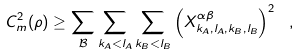Convert formula to latex. <formula><loc_0><loc_0><loc_500><loc_500>C ^ { 2 } _ { m } ( \rho ) \geq \sum _ { \mathcal { B } } \sum _ { k _ { A } < l _ { A } } \sum _ { k _ { B } < l _ { B } } \left ( X _ { k _ { A } , l _ { A } , k _ { B } , l _ { B } } ^ { \alpha \beta } \right ) ^ { 2 } \ ,</formula> 